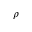Convert formula to latex. <formula><loc_0><loc_0><loc_500><loc_500>\rho</formula> 